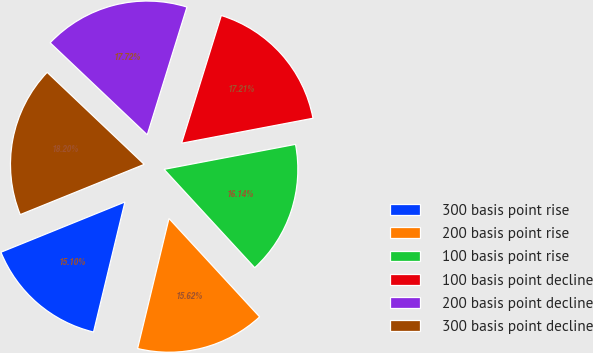<chart> <loc_0><loc_0><loc_500><loc_500><pie_chart><fcel>300 basis point rise<fcel>200 basis point rise<fcel>100 basis point rise<fcel>100 basis point decline<fcel>200 basis point decline<fcel>300 basis point decline<nl><fcel>15.1%<fcel>15.62%<fcel>16.14%<fcel>17.21%<fcel>17.72%<fcel>18.2%<nl></chart> 